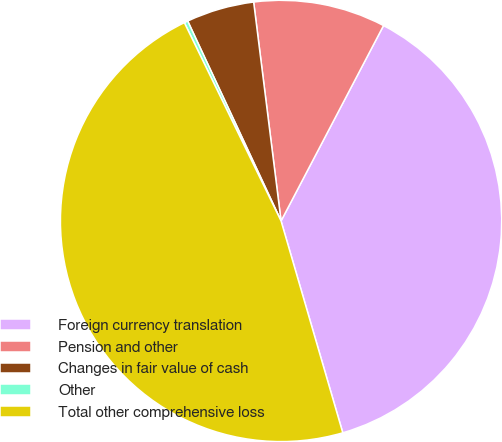<chart> <loc_0><loc_0><loc_500><loc_500><pie_chart><fcel>Foreign currency translation<fcel>Pension and other<fcel>Changes in fair value of cash<fcel>Other<fcel>Total other comprehensive loss<nl><fcel>37.8%<fcel>9.67%<fcel>4.97%<fcel>0.27%<fcel>47.29%<nl></chart> 